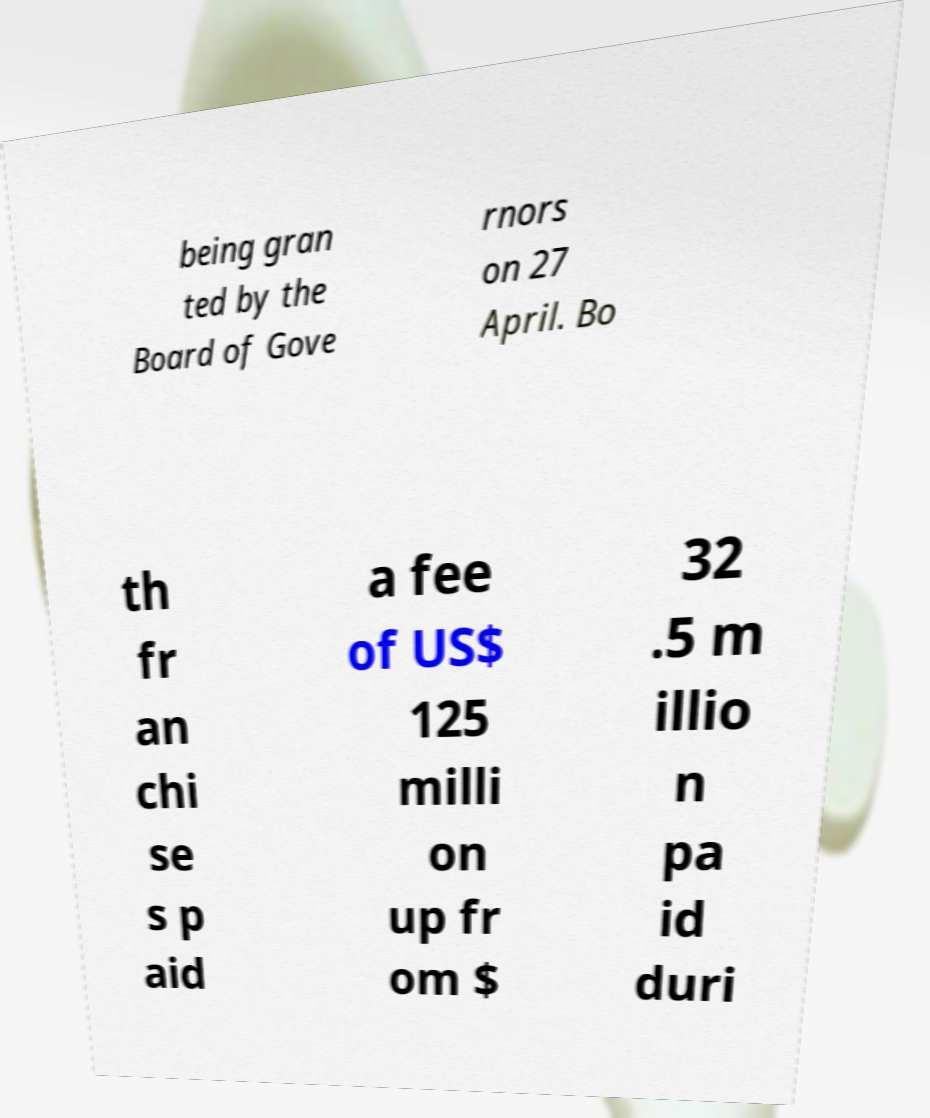Please identify and transcribe the text found in this image. being gran ted by the Board of Gove rnors on 27 April. Bo th fr an chi se s p aid a fee of US$ 125 milli on up fr om $ 32 .5 m illio n pa id duri 